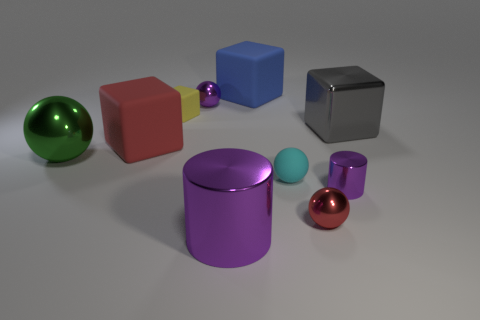What is the object with the shiniest surface, and which one has the most matte finish? The object with the shiniest surface is the green sphere, reflecting the environment with high gloss. The object with the most matte finish is the grey cube on the right side, absorbing light and lacking specular reflections. 